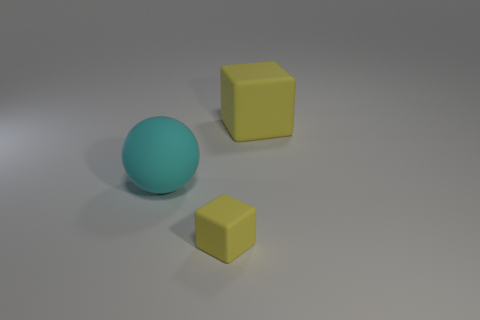Add 2 cyan things. How many objects exist? 5 Subtract all spheres. How many objects are left? 2 Add 2 big cubes. How many big cubes are left? 3 Add 1 cyan rubber balls. How many cyan rubber balls exist? 2 Subtract 0 red cylinders. How many objects are left? 3 Subtract all tiny yellow matte things. Subtract all large cyan spheres. How many objects are left? 1 